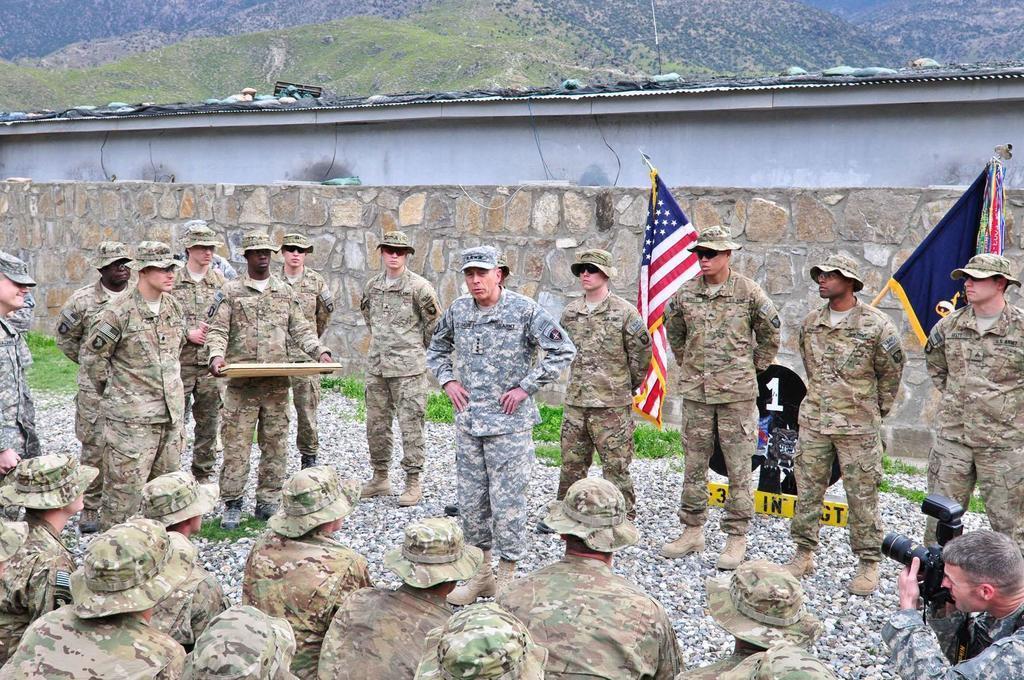In one or two sentences, can you explain what this image depicts? In this picture we can see group of people are standing on the path. Some grass is visible on the ground. There is a person holding object in his hand. We can see two flags and a compound wall from left to right. There is a number board and few stones are visible on the ground. We can see few people are sitting and a person is holding camera in his hands on bottom right. 